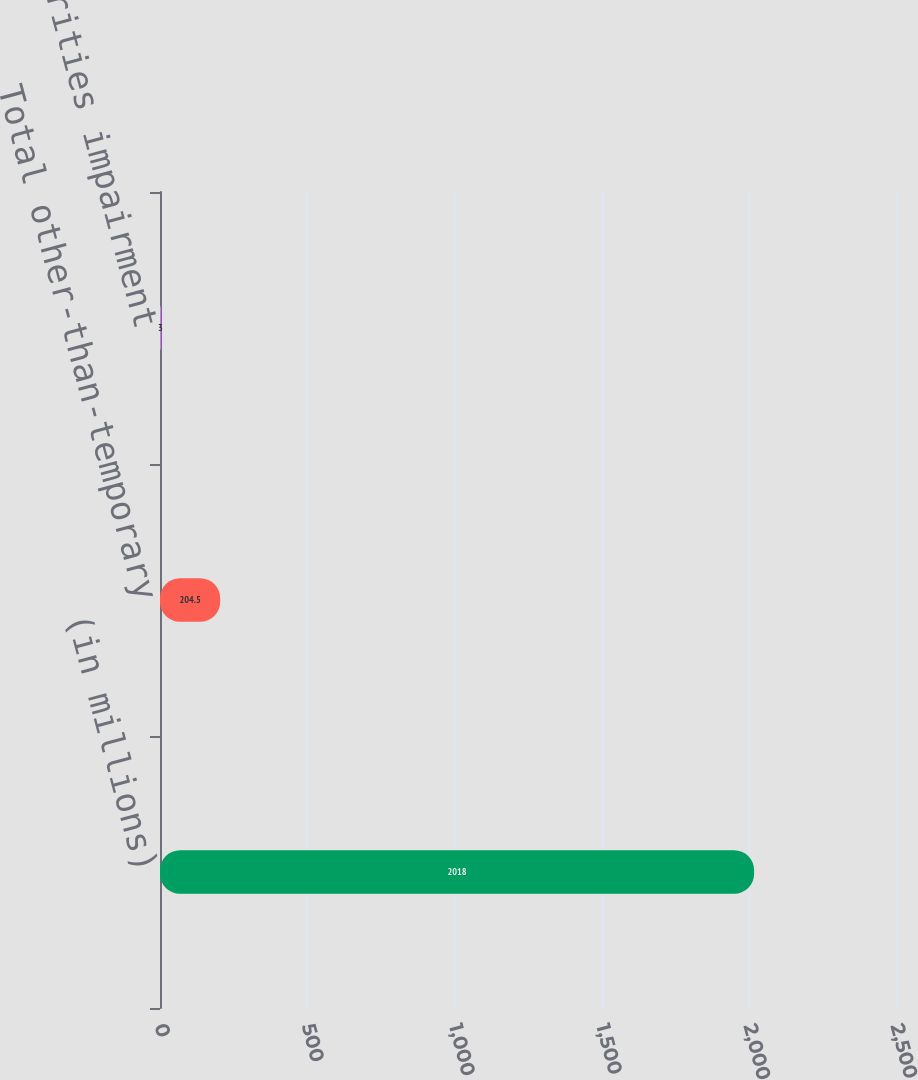<chart> <loc_0><loc_0><loc_500><loc_500><bar_chart><fcel>(in millions)<fcel>Total other-than-temporary<fcel>Net securities impairment<nl><fcel>2018<fcel>204.5<fcel>3<nl></chart> 